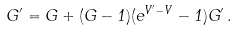<formula> <loc_0><loc_0><loc_500><loc_500>G ^ { \prime } = G + ( G - 1 ) ( e ^ { V ^ { \prime } - V } - 1 ) G ^ { \prime } \, .</formula> 